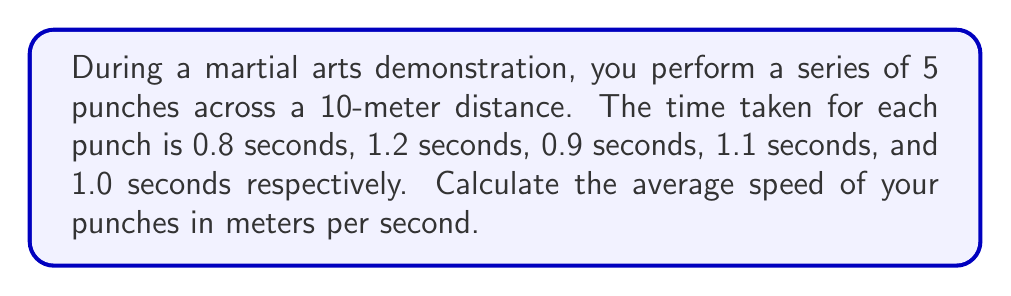Could you help me with this problem? To calculate the average speed, we need to follow these steps:

1. Calculate the total distance:
   Total distance = 10 meters

2. Calculate the total time:
   Total time = $0.8 + 1.2 + 0.9 + 1.1 + 1.0 = 5$ seconds

3. Use the formula for average speed:
   $\text{Average Speed} = \frac{\text{Total Distance}}{\text{Total Time}}$

4. Substitute the values:
   $\text{Average Speed} = \frac{10 \text{ meters}}{5 \text{ seconds}}$

5. Perform the division:
   $\text{Average Speed} = 2 \text{ meters per second}$

Therefore, the average speed of your punches during the demonstration is 2 meters per second.
Answer: $2 \text{ m/s}$ 